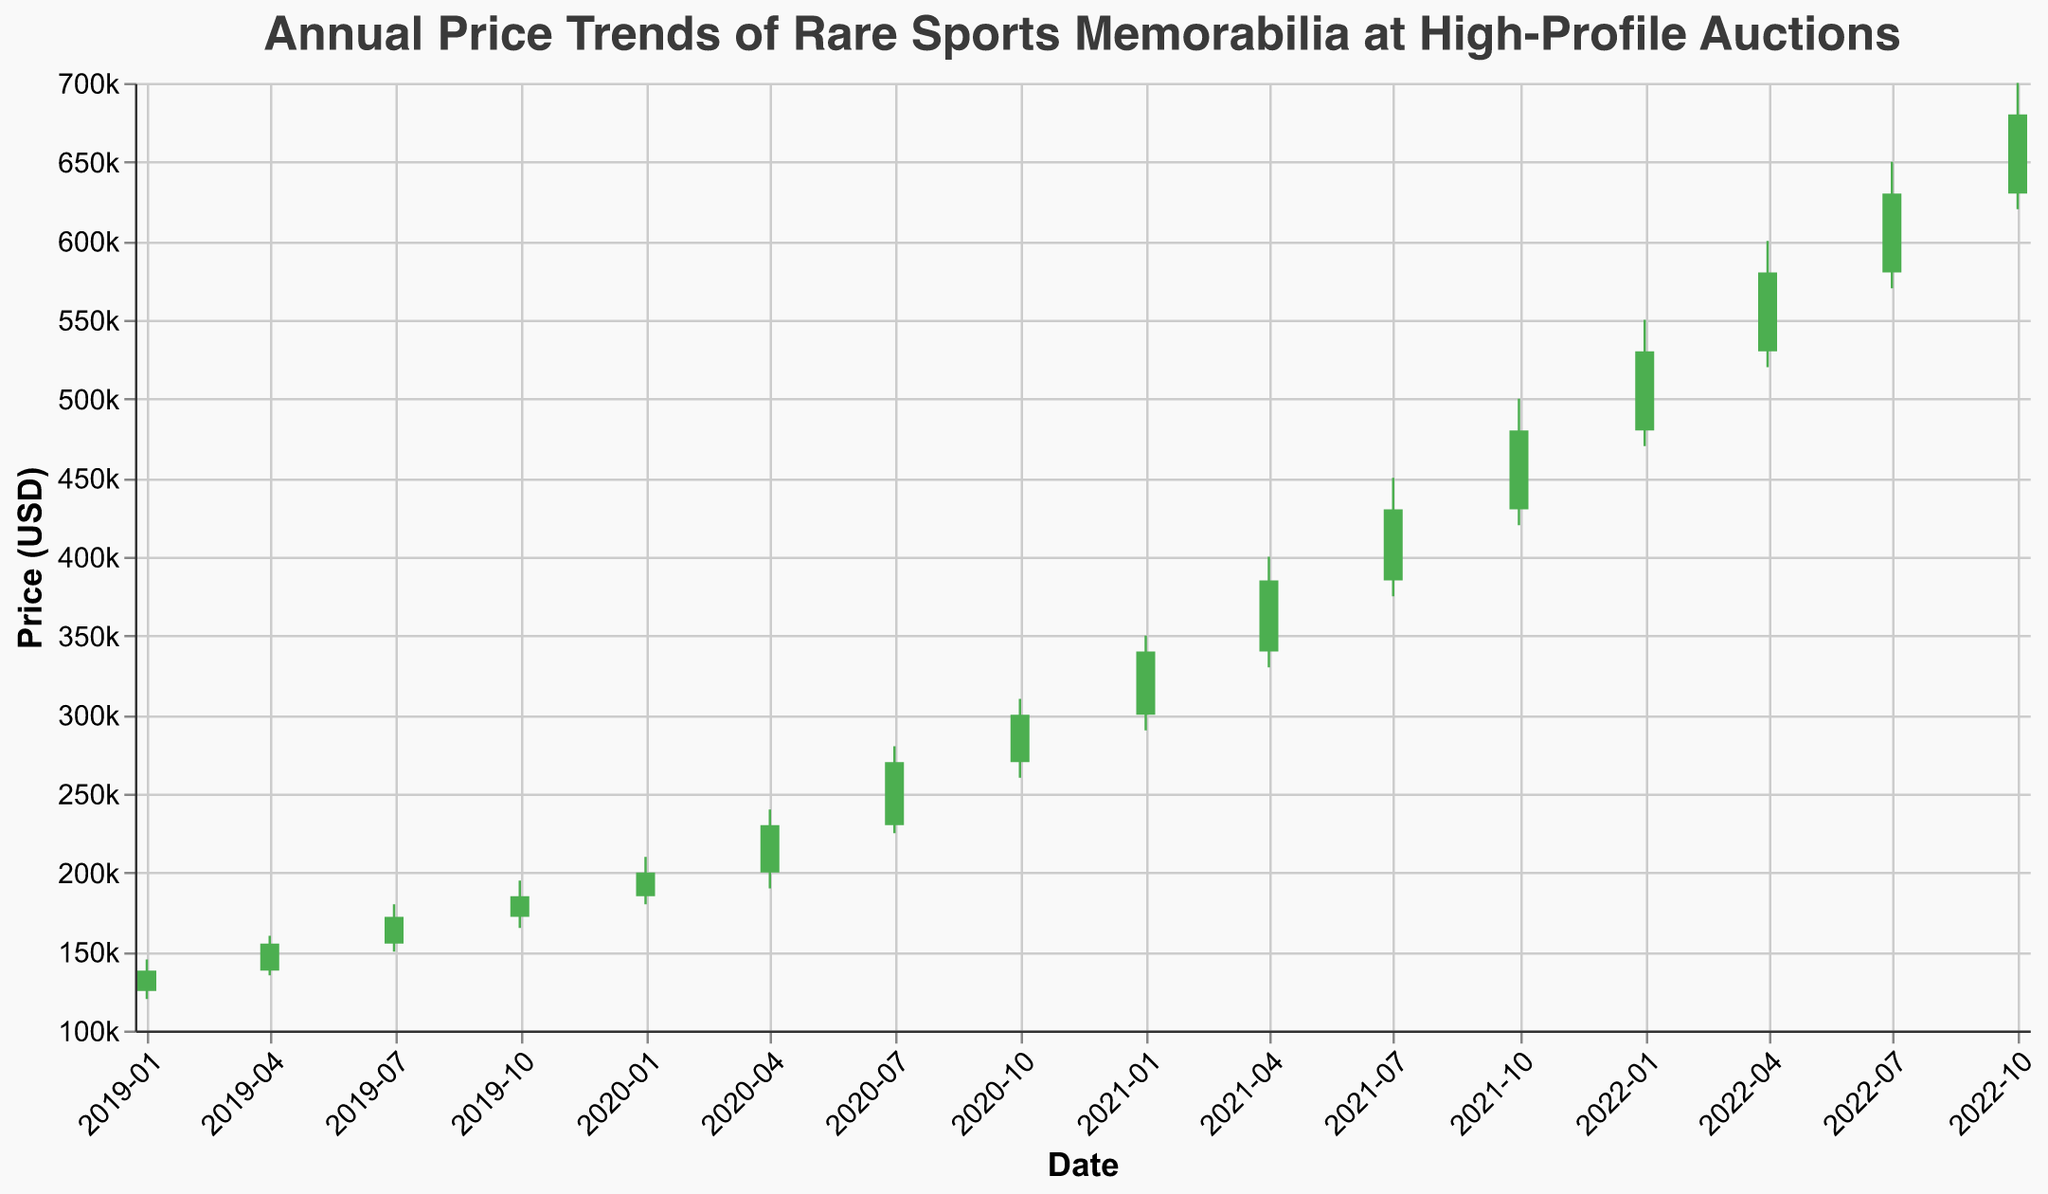what is the title of the figure? The title of the figure is displayed at the top of the chart to provide an overview of what the data represents. In this chart, it mentions the specific subject of the data being displayed. "Annual Price Trends of Rare Sports Memorabilia at High-Profile Auctions" is clearly the title at the top.
Answer: Annual Price Trends of Rare Sports Memorabilia at High-profile Auctions What is the price range shown for 2020-07-01? To find this, look at the specific "candlestick" (bar + rule) representing 2020-07-01. The highest point indicates the high price, and the lowest point indicates the low price. For 2020-07-01, the high is 280,000 and the low is 225,000.
Answer: 225,000 to 280,000 Between 2020 and 2022, which quarter saw the highest closing price? Observe the closing price values (end of the bar). In the whole year 2022, 2022-10-01 (fourth quarter of 2022) shows the highest closing price of 680,000.
Answer: 2022-10-01 Which quarter had the lowest opening price across the entire timeline? Look at the opening price values (base of the bar). The first quarter of 2019 (2019-01-01) has the lowest opening price of 125,000.
Answer: 2019-01-01 How much did the close price change from the first quarter of 2019 to the first quarter of 2020? Check the closing prices for both dates: For 2019-01-01, it's 138,000; for 2020-01-01, it's 200,000. The change is found by subtracting 138,000 from 200,000, which is 62,000.
Answer: 62,000 What was the main trend observed in the closing prices from 2019 to 2022? Inspect the chart pattern for the closing prices from 2019 to 2022. The trend is consistently upward over time, indicating rising prices.
Answer: Upward trend Which quarter had the largest difference between the high and low prices within a single quarter? To find this, calculate the difference between the high and low for each quarter. The largest difference appears for 2021-10-01: 500,000 (high) - 420,000 (low) = 80,000.
Answer: 2021-10-01 In which year did the prices generally start above 200,000? Analyze the opening prices of the bars. Starting from 2020-01-01 onward, the opening prices are consistently over 200,000.
Answer: 2020 Which quarter showed the greatest increase in closing price compared to the previous quarter? Compare the closing prices sequentially for each date. From 2020-04-01 to 2020-07-01, the closing price increased from 230,000 to 270,000, a rise of 40,000.
Answer: 2020-07-01 Were there any quarters where the closing price was lower than the opening price? Identify bars where the color is red (indicating a decrease in closing price). There are no red bars in this chart, meaning no quarters had a closing price lower than the opening.
Answer: No 